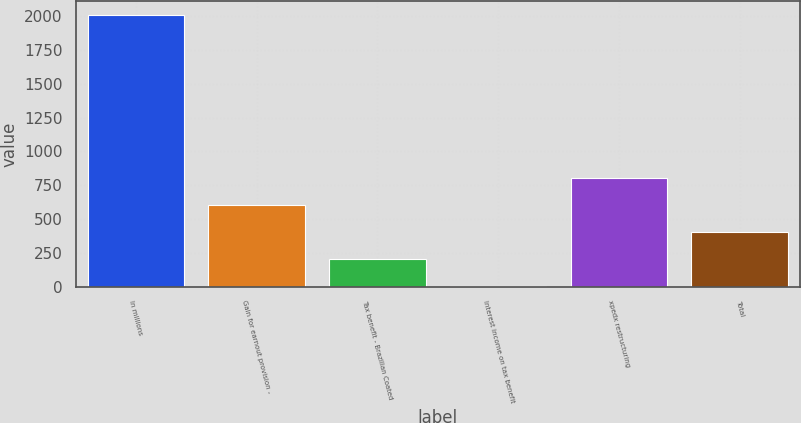Convert chart. <chart><loc_0><loc_0><loc_500><loc_500><bar_chart><fcel>In millions<fcel>Gain for earnout provision -<fcel>Tax benefit - Brazilian Coated<fcel>Interest income on tax benefit<fcel>xpedx restructuring<fcel>Total<nl><fcel>2011<fcel>606.1<fcel>204.7<fcel>4<fcel>806.8<fcel>405.4<nl></chart> 